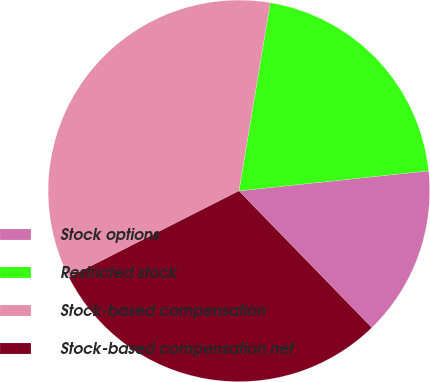Convert chart. <chart><loc_0><loc_0><loc_500><loc_500><pie_chart><fcel>Stock options<fcel>Restricted stock<fcel>Stock-based compensation<fcel>Stock-based compensation net<nl><fcel>14.4%<fcel>20.7%<fcel>35.1%<fcel>29.8%<nl></chart> 